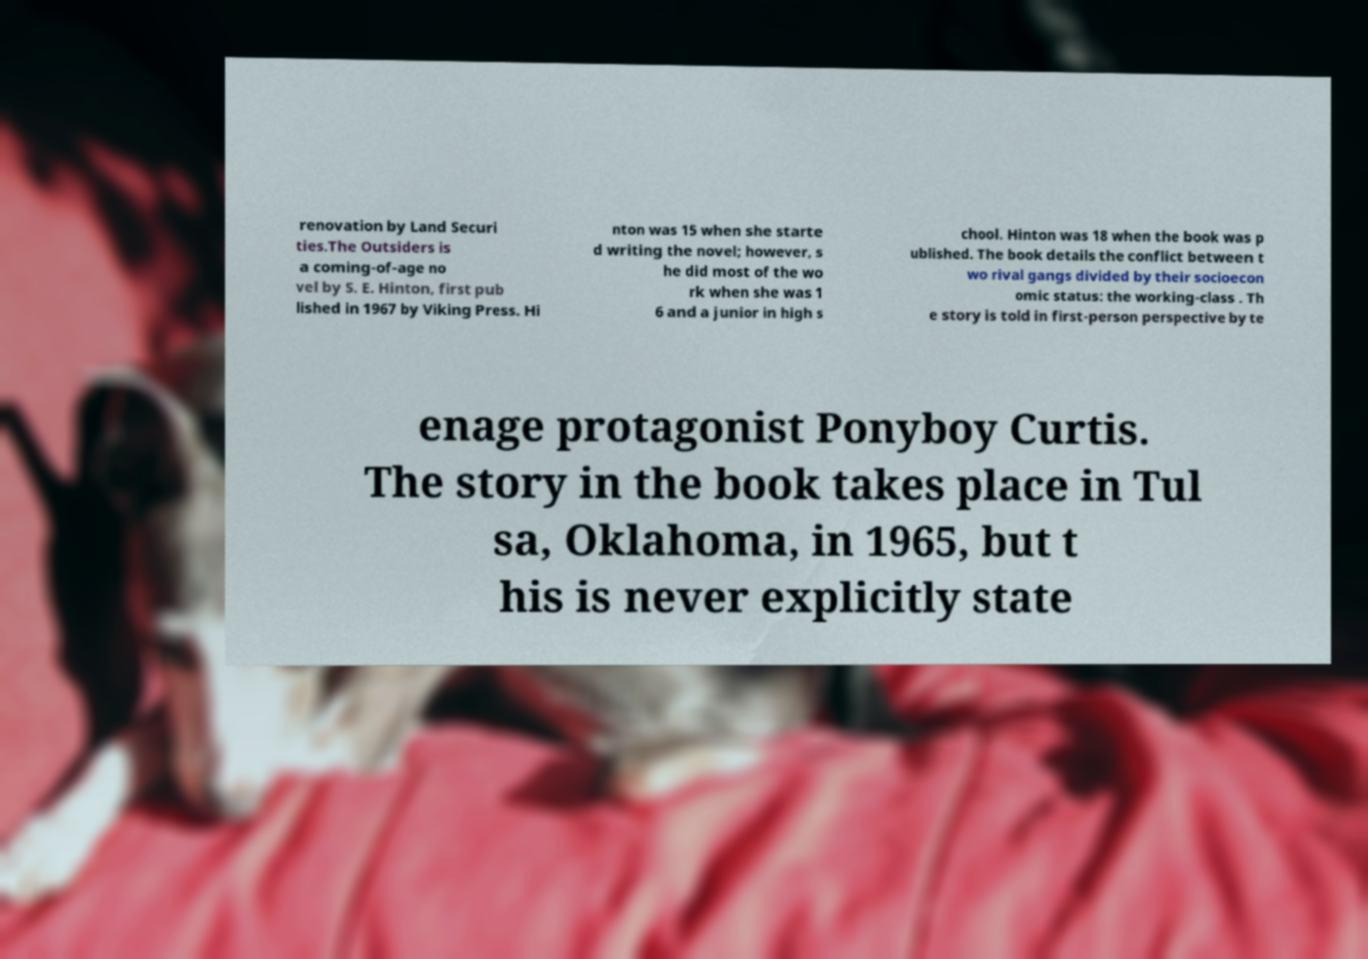Please identify and transcribe the text found in this image. renovation by Land Securi ties.The Outsiders is a coming-of-age no vel by S. E. Hinton, first pub lished in 1967 by Viking Press. Hi nton was 15 when she starte d writing the novel; however, s he did most of the wo rk when she was 1 6 and a junior in high s chool. Hinton was 18 when the book was p ublished. The book details the conflict between t wo rival gangs divided by their socioecon omic status: the working-class . Th e story is told in first-person perspective by te enage protagonist Ponyboy Curtis. The story in the book takes place in Tul sa, Oklahoma, in 1965, but t his is never explicitly state 